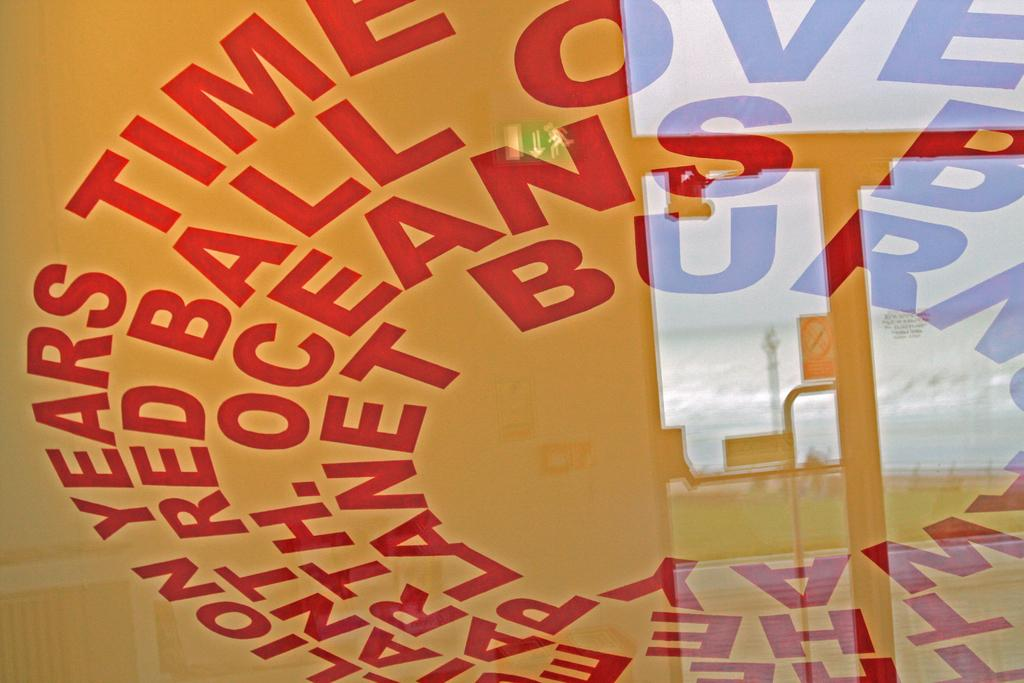Provide a one-sentence caption for the provided image. Words in red with years and time are in a circle. 